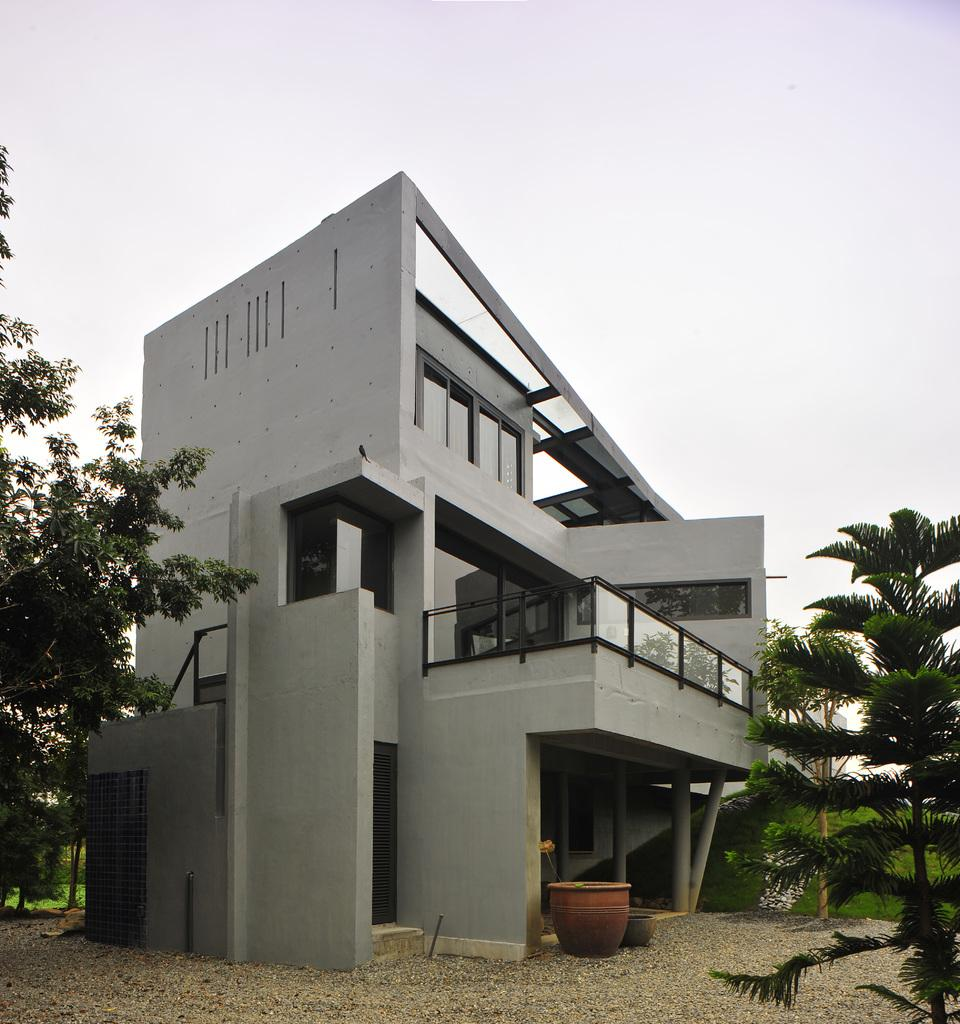What is located on the right side of the image in the foreground? There is a tree in the foreground on the right side of the image. What can be seen in the background of the image? There is a building and a drum-like object in the background of the image. What type of surface is visible in the image? The ground is visible in the image. Are there any other trees visible in the image? Yes, there is another tree in the background of the image. What is visible at the top of the image? The sky is visible at the top of the image. How many clocks are hanging on the tree in the image? There are no clocks present on the tree in the image. What type of truck can be seen driving through the building in the image? There is no truck present in the image, nor is there any indication of a truck driving through the building. 